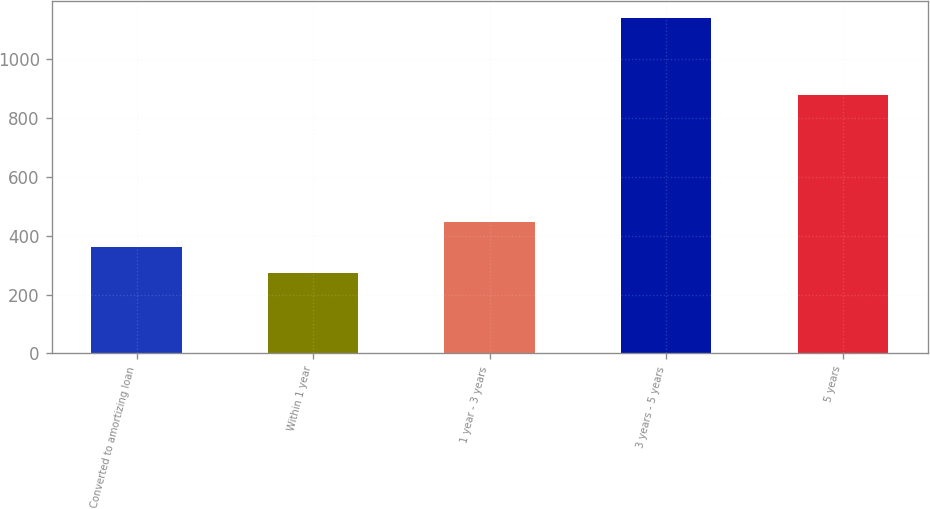Convert chart. <chart><loc_0><loc_0><loc_500><loc_500><bar_chart><fcel>Converted to amortizing loan<fcel>Within 1 year<fcel>1 year - 3 years<fcel>3 years - 5 years<fcel>5 years<nl><fcel>360.5<fcel>274<fcel>447<fcel>1139<fcel>879<nl></chart> 